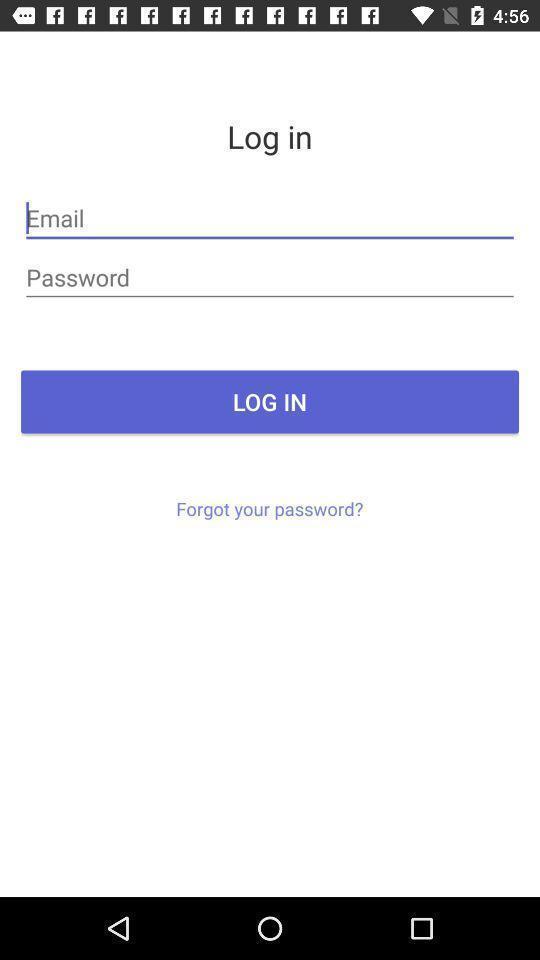Explain the elements present in this screenshot. Social app login page with credentials. 